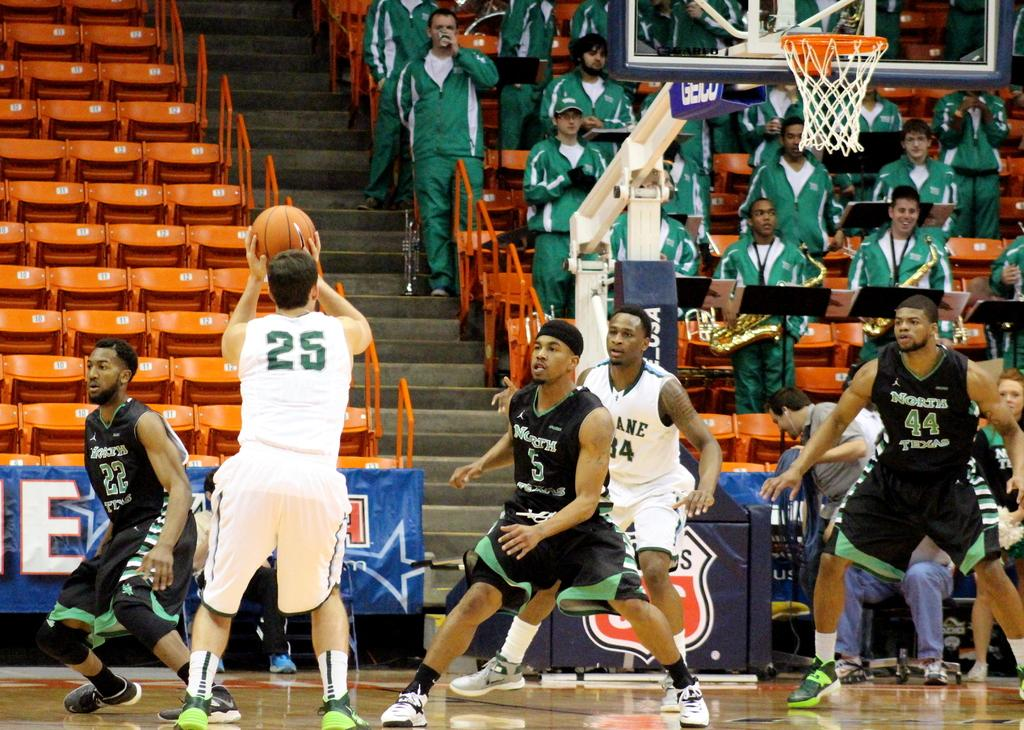What is happening in the image involving the group of people? The people are standing and watching someone play. What is the person holding in the image? The person is holding a ball. Can you describe the seating arrangement in the image? There are chairs on the stairs in the image. What type of honey can be seen dripping from the ball in the image? There is no honey present in the image, and the ball is not depicted as dripping anything. 